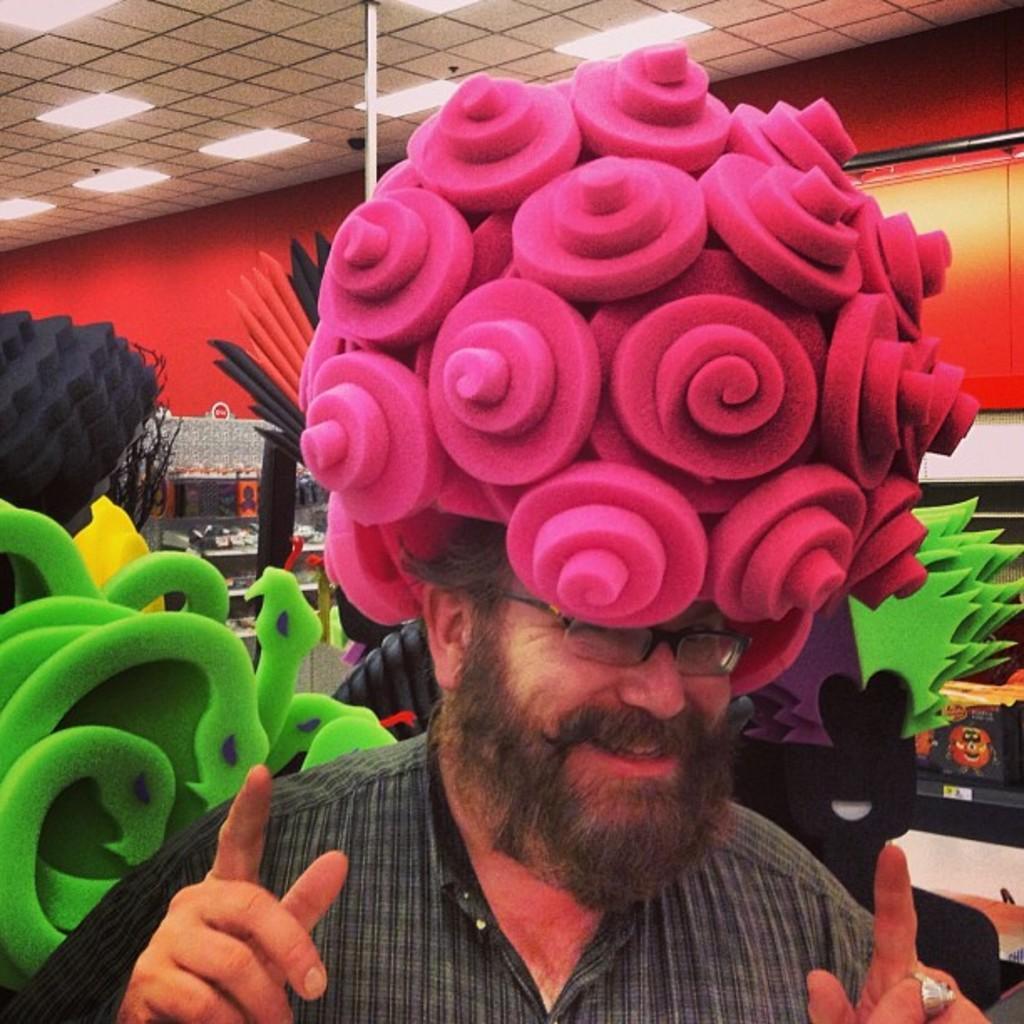Can you describe this image briefly? In this image there is one person standing and wearing a different kind of cap, and there are some objects in the background and there are some lights arranged at top of this image. 